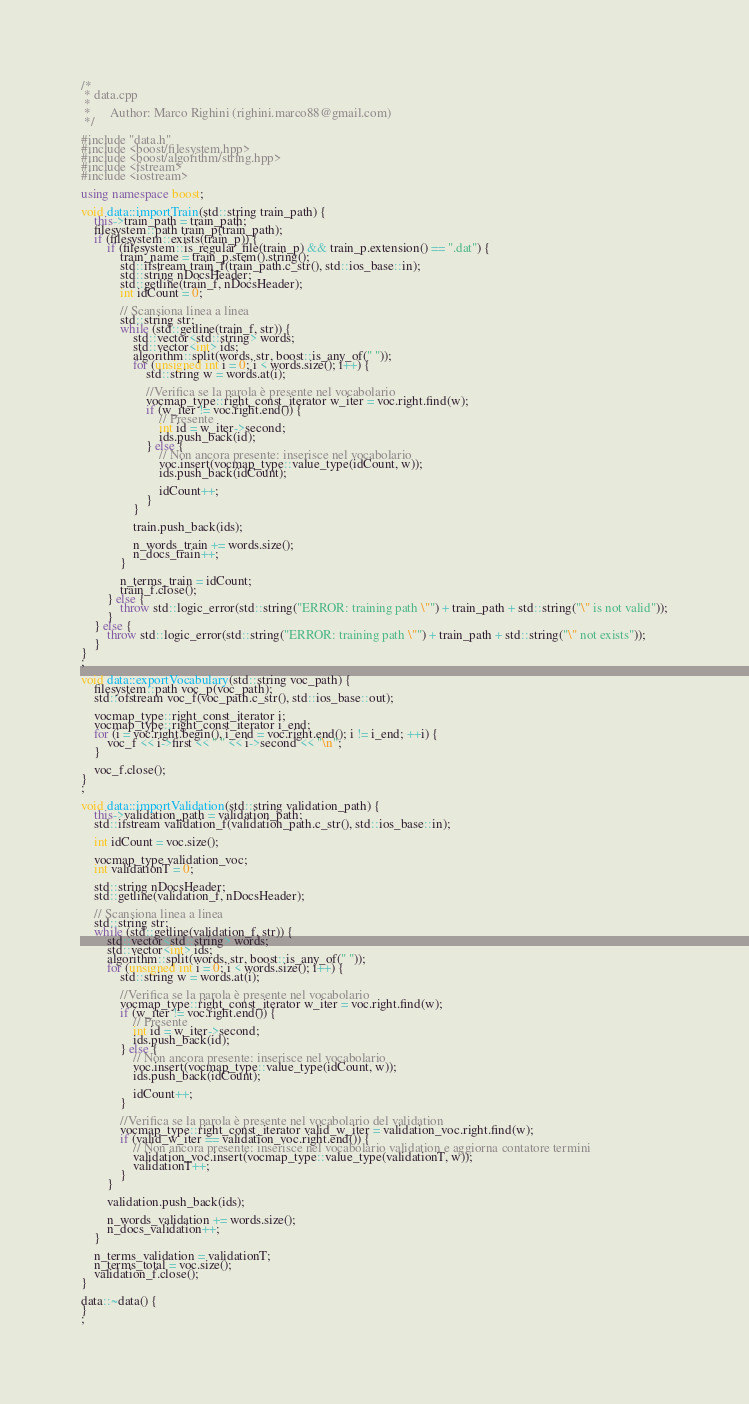Convert code to text. <code><loc_0><loc_0><loc_500><loc_500><_C++_>/*
 * data.cpp
 *
 *      Author: Marco Righini (righini.marco88@gmail.com)
 */

#include "data.h"
#include <boost/filesystem.hpp>
#include <boost/algorithm/string.hpp>
#include <fstream>
#include <iostream>

using namespace boost;

void data::importTrain(std::string train_path) {
	this->train_path = train_path;
	filesystem::path train_p(train_path);
	if (filesystem::exists(train_p)) {
		if (filesystem::is_regular_file(train_p) && train_p.extension() == ".dat") {
			train_name = train_p.stem().string();
			std::ifstream train_f(train_path.c_str(), std::ios_base::in);
			std::string nDocsHeader;
			std::getline(train_f, nDocsHeader);
			int idCount = 0;

			// Scansiona linea a linea
			std::string str;
			while (std::getline(train_f, str)) {
				std::vector<std::string> words;
				std::vector<int> ids;
				algorithm::split(words, str, boost::is_any_of(" "));
				for (unsigned int i = 0; i < words.size(); i++) {
					std::string w = words.at(i);

					//Verifica se la parola è presente nel vocabolario
					vocmap_type::right_const_iterator w_iter = voc.right.find(w);
					if (w_iter != voc.right.end()) {
						// Presente
						int id = w_iter->second;
						ids.push_back(id);
					} else {
						// Non ancora presente: inserisce nel vocabolario
						voc.insert(vocmap_type::value_type(idCount, w));
						ids.push_back(idCount);

						idCount++;
					}
				}

				train.push_back(ids);

				n_words_train += words.size();
				n_docs_train++;
			}

			n_terms_train = idCount;
			train_f.close();
		} else {
			throw std::logic_error(std::string("ERROR: training path \"") + train_path + std::string("\" is not valid"));
		}
	} else {
		throw std::logic_error(std::string("ERROR: training path \"") + train_path + std::string("\" not exists"));
	}
}
;

void data::exportVocabulary(std::string voc_path) {
	filesystem::path voc_p(voc_path);
	std::ofstream voc_f(voc_path.c_str(), std::ios_base::out);

	vocmap_type::right_const_iterator i;
	vocmap_type::right_const_iterator i_end;
	for (i = voc.right.begin(), i_end = voc.right.end(); i != i_end; ++i) {
		voc_f << i->first << " " << i->second << "\n";
	}

	voc_f.close();
}
;

void data::importValidation(std::string validation_path) {
	this->validation_path = validation_path;
	std::ifstream validation_f(validation_path.c_str(), std::ios_base::in);

	int idCount = voc.size();

	vocmap_type validation_voc;
	int validationT = 0;

	std::string nDocsHeader;
	std::getline(validation_f, nDocsHeader);

	// Scansiona linea a linea
	std::string str;
	while (std::getline(validation_f, str)) {
		std::vector<std::string> words;
		std::vector<int> ids;
		algorithm::split(words, str, boost::is_any_of(" "));
		for (unsigned int i = 0; i < words.size(); i++) {
			std::string w = words.at(i);

			//Verifica se la parola è presente nel vocabolario
			vocmap_type::right_const_iterator w_iter = voc.right.find(w);
			if (w_iter != voc.right.end()) {
				// Presente
				int id = w_iter->second;
				ids.push_back(id);
			} else {
				// Non ancora presente: inserisce nel vocabolario
				voc.insert(vocmap_type::value_type(idCount, w));
				ids.push_back(idCount);

				idCount++;
			}

			//Verifica se la parola è presente nel vocabolario del validation
			vocmap_type::right_const_iterator valid_w_iter = validation_voc.right.find(w);
			if (valid_w_iter == validation_voc.right.end()) {
				// Non ancora presente: inserisce nel vocabolario validation e aggiorna contatore termini
				validation_voc.insert(vocmap_type::value_type(validationT, w));
				validationT++;
			}
		}

		validation.push_back(ids);

		n_words_validation += words.size();
		n_docs_validation++;
	}

	n_terms_validation = validationT;
	n_terms_total = voc.size();
	validation_f.close();
}

data::~data() {
}
;

</code> 